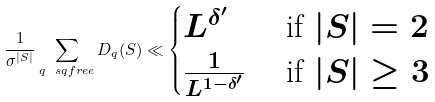Convert formula to latex. <formula><loc_0><loc_0><loc_500><loc_500>\frac { 1 } { \sigma ^ { | S | } } \sum _ { q \ s q f r e e } D _ { q } ( S ) \ll \begin{cases} L ^ { \delta ^ { \prime } } & \text { if } | S | = 2 \\ \frac { 1 } { L ^ { 1 - \delta ^ { \prime } } } & \text { if } | S | \geq 3 \end{cases}</formula> 